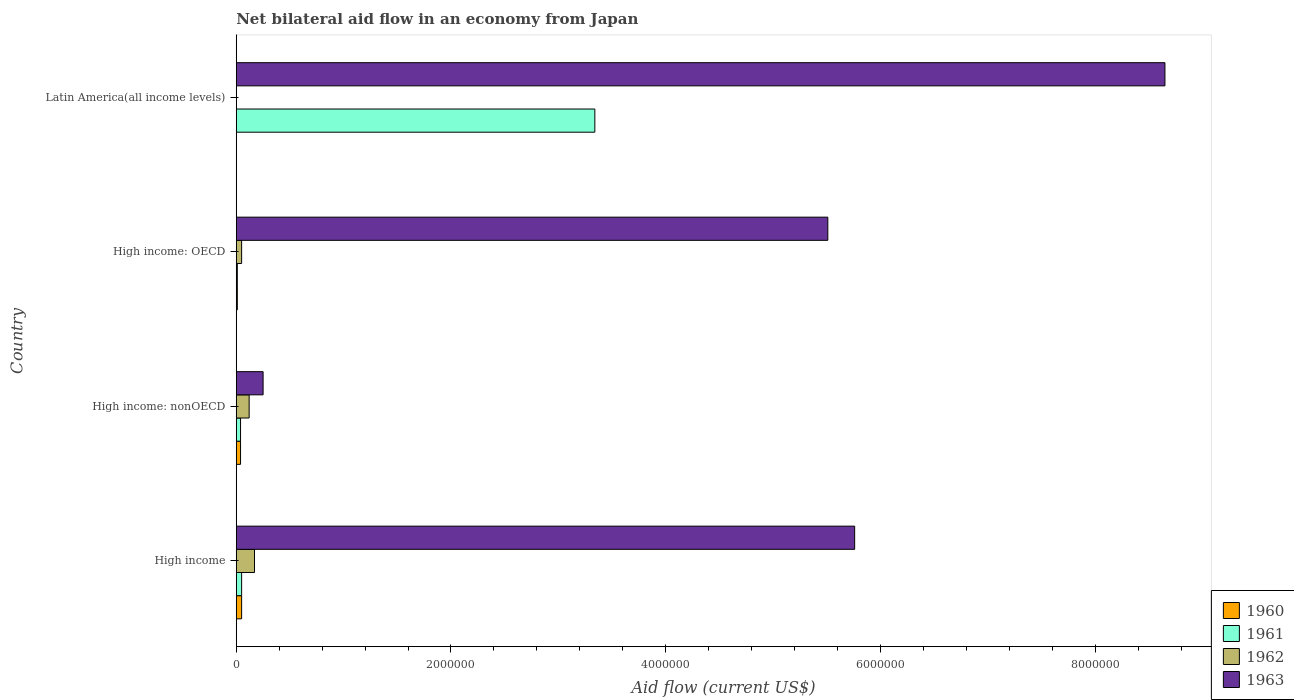What is the label of the 4th group of bars from the top?
Keep it short and to the point. High income. In how many cases, is the number of bars for a given country not equal to the number of legend labels?
Your response must be concise. 1. What is the net bilateral aid flow in 1961 in High income: OECD?
Your response must be concise. 10000. Across all countries, what is the maximum net bilateral aid flow in 1963?
Give a very brief answer. 8.65e+06. Across all countries, what is the minimum net bilateral aid flow in 1962?
Your answer should be very brief. 0. What is the difference between the net bilateral aid flow in 1963 in High income and that in Latin America(all income levels)?
Your answer should be compact. -2.89e+06. What is the average net bilateral aid flow in 1963 per country?
Give a very brief answer. 5.04e+06. What is the difference between the net bilateral aid flow in 1960 and net bilateral aid flow in 1963 in High income: OECD?
Give a very brief answer. -5.50e+06. In how many countries, is the net bilateral aid flow in 1963 greater than 2800000 US$?
Provide a short and direct response. 3. What is the difference between the highest and the second highest net bilateral aid flow in 1961?
Offer a very short reply. 3.29e+06. What is the difference between the highest and the lowest net bilateral aid flow in 1963?
Provide a succinct answer. 8.40e+06. In how many countries, is the net bilateral aid flow in 1961 greater than the average net bilateral aid flow in 1961 taken over all countries?
Offer a very short reply. 1. What is the difference between two consecutive major ticks on the X-axis?
Provide a short and direct response. 2.00e+06. Are the values on the major ticks of X-axis written in scientific E-notation?
Your answer should be compact. No. Does the graph contain any zero values?
Your answer should be very brief. Yes. Where does the legend appear in the graph?
Your answer should be compact. Bottom right. How many legend labels are there?
Give a very brief answer. 4. What is the title of the graph?
Offer a very short reply. Net bilateral aid flow in an economy from Japan. Does "1978" appear as one of the legend labels in the graph?
Offer a terse response. No. What is the Aid flow (current US$) of 1960 in High income?
Provide a succinct answer. 5.00e+04. What is the Aid flow (current US$) of 1963 in High income?
Provide a succinct answer. 5.76e+06. What is the Aid flow (current US$) in 1961 in High income: nonOECD?
Your response must be concise. 4.00e+04. What is the Aid flow (current US$) in 1962 in High income: nonOECD?
Give a very brief answer. 1.20e+05. What is the Aid flow (current US$) in 1963 in High income: nonOECD?
Offer a very short reply. 2.50e+05. What is the Aid flow (current US$) in 1963 in High income: OECD?
Give a very brief answer. 5.51e+06. What is the Aid flow (current US$) of 1960 in Latin America(all income levels)?
Make the answer very short. 0. What is the Aid flow (current US$) in 1961 in Latin America(all income levels)?
Make the answer very short. 3.34e+06. What is the Aid flow (current US$) of 1963 in Latin America(all income levels)?
Provide a succinct answer. 8.65e+06. Across all countries, what is the maximum Aid flow (current US$) in 1960?
Offer a terse response. 5.00e+04. Across all countries, what is the maximum Aid flow (current US$) in 1961?
Your answer should be compact. 3.34e+06. Across all countries, what is the maximum Aid flow (current US$) in 1962?
Your response must be concise. 1.70e+05. Across all countries, what is the maximum Aid flow (current US$) of 1963?
Your answer should be compact. 8.65e+06. Across all countries, what is the minimum Aid flow (current US$) of 1961?
Offer a terse response. 10000. Across all countries, what is the minimum Aid flow (current US$) of 1962?
Provide a short and direct response. 0. Across all countries, what is the minimum Aid flow (current US$) of 1963?
Your answer should be very brief. 2.50e+05. What is the total Aid flow (current US$) in 1961 in the graph?
Ensure brevity in your answer.  3.44e+06. What is the total Aid flow (current US$) in 1962 in the graph?
Your response must be concise. 3.40e+05. What is the total Aid flow (current US$) of 1963 in the graph?
Your response must be concise. 2.02e+07. What is the difference between the Aid flow (current US$) of 1961 in High income and that in High income: nonOECD?
Provide a short and direct response. 10000. What is the difference between the Aid flow (current US$) in 1963 in High income and that in High income: nonOECD?
Your response must be concise. 5.51e+06. What is the difference between the Aid flow (current US$) in 1960 in High income and that in High income: OECD?
Ensure brevity in your answer.  4.00e+04. What is the difference between the Aid flow (current US$) of 1961 in High income and that in High income: OECD?
Give a very brief answer. 4.00e+04. What is the difference between the Aid flow (current US$) of 1962 in High income and that in High income: OECD?
Provide a short and direct response. 1.20e+05. What is the difference between the Aid flow (current US$) of 1961 in High income and that in Latin America(all income levels)?
Provide a succinct answer. -3.29e+06. What is the difference between the Aid flow (current US$) in 1963 in High income and that in Latin America(all income levels)?
Offer a very short reply. -2.89e+06. What is the difference between the Aid flow (current US$) of 1960 in High income: nonOECD and that in High income: OECD?
Your answer should be compact. 3.00e+04. What is the difference between the Aid flow (current US$) in 1961 in High income: nonOECD and that in High income: OECD?
Provide a succinct answer. 3.00e+04. What is the difference between the Aid flow (current US$) in 1963 in High income: nonOECD and that in High income: OECD?
Offer a terse response. -5.26e+06. What is the difference between the Aid flow (current US$) of 1961 in High income: nonOECD and that in Latin America(all income levels)?
Make the answer very short. -3.30e+06. What is the difference between the Aid flow (current US$) of 1963 in High income: nonOECD and that in Latin America(all income levels)?
Your response must be concise. -8.40e+06. What is the difference between the Aid flow (current US$) in 1961 in High income: OECD and that in Latin America(all income levels)?
Ensure brevity in your answer.  -3.33e+06. What is the difference between the Aid flow (current US$) of 1963 in High income: OECD and that in Latin America(all income levels)?
Provide a short and direct response. -3.14e+06. What is the difference between the Aid flow (current US$) of 1960 in High income and the Aid flow (current US$) of 1961 in High income: nonOECD?
Keep it short and to the point. 10000. What is the difference between the Aid flow (current US$) of 1960 in High income and the Aid flow (current US$) of 1962 in High income: nonOECD?
Keep it short and to the point. -7.00e+04. What is the difference between the Aid flow (current US$) of 1960 in High income and the Aid flow (current US$) of 1963 in High income: nonOECD?
Keep it short and to the point. -2.00e+05. What is the difference between the Aid flow (current US$) of 1961 in High income and the Aid flow (current US$) of 1963 in High income: nonOECD?
Your response must be concise. -2.00e+05. What is the difference between the Aid flow (current US$) of 1962 in High income and the Aid flow (current US$) of 1963 in High income: nonOECD?
Provide a short and direct response. -8.00e+04. What is the difference between the Aid flow (current US$) in 1960 in High income and the Aid flow (current US$) in 1961 in High income: OECD?
Ensure brevity in your answer.  4.00e+04. What is the difference between the Aid flow (current US$) of 1960 in High income and the Aid flow (current US$) of 1962 in High income: OECD?
Give a very brief answer. 0. What is the difference between the Aid flow (current US$) of 1960 in High income and the Aid flow (current US$) of 1963 in High income: OECD?
Your answer should be very brief. -5.46e+06. What is the difference between the Aid flow (current US$) of 1961 in High income and the Aid flow (current US$) of 1962 in High income: OECD?
Give a very brief answer. 0. What is the difference between the Aid flow (current US$) in 1961 in High income and the Aid flow (current US$) in 1963 in High income: OECD?
Provide a succinct answer. -5.46e+06. What is the difference between the Aid flow (current US$) of 1962 in High income and the Aid flow (current US$) of 1963 in High income: OECD?
Your answer should be very brief. -5.34e+06. What is the difference between the Aid flow (current US$) in 1960 in High income and the Aid flow (current US$) in 1961 in Latin America(all income levels)?
Provide a succinct answer. -3.29e+06. What is the difference between the Aid flow (current US$) of 1960 in High income and the Aid flow (current US$) of 1963 in Latin America(all income levels)?
Keep it short and to the point. -8.60e+06. What is the difference between the Aid flow (current US$) of 1961 in High income and the Aid flow (current US$) of 1963 in Latin America(all income levels)?
Ensure brevity in your answer.  -8.60e+06. What is the difference between the Aid flow (current US$) of 1962 in High income and the Aid flow (current US$) of 1963 in Latin America(all income levels)?
Ensure brevity in your answer.  -8.48e+06. What is the difference between the Aid flow (current US$) of 1960 in High income: nonOECD and the Aid flow (current US$) of 1961 in High income: OECD?
Offer a terse response. 3.00e+04. What is the difference between the Aid flow (current US$) in 1960 in High income: nonOECD and the Aid flow (current US$) in 1963 in High income: OECD?
Ensure brevity in your answer.  -5.47e+06. What is the difference between the Aid flow (current US$) of 1961 in High income: nonOECD and the Aid flow (current US$) of 1962 in High income: OECD?
Provide a short and direct response. -10000. What is the difference between the Aid flow (current US$) of 1961 in High income: nonOECD and the Aid flow (current US$) of 1963 in High income: OECD?
Ensure brevity in your answer.  -5.47e+06. What is the difference between the Aid flow (current US$) of 1962 in High income: nonOECD and the Aid flow (current US$) of 1963 in High income: OECD?
Offer a terse response. -5.39e+06. What is the difference between the Aid flow (current US$) of 1960 in High income: nonOECD and the Aid flow (current US$) of 1961 in Latin America(all income levels)?
Give a very brief answer. -3.30e+06. What is the difference between the Aid flow (current US$) in 1960 in High income: nonOECD and the Aid flow (current US$) in 1963 in Latin America(all income levels)?
Provide a succinct answer. -8.61e+06. What is the difference between the Aid flow (current US$) of 1961 in High income: nonOECD and the Aid flow (current US$) of 1963 in Latin America(all income levels)?
Give a very brief answer. -8.61e+06. What is the difference between the Aid flow (current US$) of 1962 in High income: nonOECD and the Aid flow (current US$) of 1963 in Latin America(all income levels)?
Provide a succinct answer. -8.53e+06. What is the difference between the Aid flow (current US$) of 1960 in High income: OECD and the Aid flow (current US$) of 1961 in Latin America(all income levels)?
Provide a succinct answer. -3.33e+06. What is the difference between the Aid flow (current US$) of 1960 in High income: OECD and the Aid flow (current US$) of 1963 in Latin America(all income levels)?
Your answer should be very brief. -8.64e+06. What is the difference between the Aid flow (current US$) in 1961 in High income: OECD and the Aid flow (current US$) in 1963 in Latin America(all income levels)?
Provide a short and direct response. -8.64e+06. What is the difference between the Aid flow (current US$) in 1962 in High income: OECD and the Aid flow (current US$) in 1963 in Latin America(all income levels)?
Offer a very short reply. -8.60e+06. What is the average Aid flow (current US$) of 1960 per country?
Provide a succinct answer. 2.50e+04. What is the average Aid flow (current US$) in 1961 per country?
Give a very brief answer. 8.60e+05. What is the average Aid flow (current US$) of 1962 per country?
Your answer should be compact. 8.50e+04. What is the average Aid flow (current US$) of 1963 per country?
Your answer should be compact. 5.04e+06. What is the difference between the Aid flow (current US$) of 1960 and Aid flow (current US$) of 1963 in High income?
Your answer should be very brief. -5.71e+06. What is the difference between the Aid flow (current US$) of 1961 and Aid flow (current US$) of 1962 in High income?
Give a very brief answer. -1.20e+05. What is the difference between the Aid flow (current US$) in 1961 and Aid flow (current US$) in 1963 in High income?
Your answer should be very brief. -5.71e+06. What is the difference between the Aid flow (current US$) in 1962 and Aid flow (current US$) in 1963 in High income?
Make the answer very short. -5.59e+06. What is the difference between the Aid flow (current US$) of 1960 and Aid flow (current US$) of 1961 in High income: nonOECD?
Keep it short and to the point. 0. What is the difference between the Aid flow (current US$) in 1961 and Aid flow (current US$) in 1962 in High income: nonOECD?
Your answer should be compact. -8.00e+04. What is the difference between the Aid flow (current US$) in 1962 and Aid flow (current US$) in 1963 in High income: nonOECD?
Give a very brief answer. -1.30e+05. What is the difference between the Aid flow (current US$) in 1960 and Aid flow (current US$) in 1961 in High income: OECD?
Offer a terse response. 0. What is the difference between the Aid flow (current US$) in 1960 and Aid flow (current US$) in 1963 in High income: OECD?
Your response must be concise. -5.50e+06. What is the difference between the Aid flow (current US$) in 1961 and Aid flow (current US$) in 1962 in High income: OECD?
Give a very brief answer. -4.00e+04. What is the difference between the Aid flow (current US$) of 1961 and Aid flow (current US$) of 1963 in High income: OECD?
Keep it short and to the point. -5.50e+06. What is the difference between the Aid flow (current US$) of 1962 and Aid flow (current US$) of 1963 in High income: OECD?
Your answer should be compact. -5.46e+06. What is the difference between the Aid flow (current US$) in 1961 and Aid flow (current US$) in 1963 in Latin America(all income levels)?
Make the answer very short. -5.31e+06. What is the ratio of the Aid flow (current US$) of 1960 in High income to that in High income: nonOECD?
Make the answer very short. 1.25. What is the ratio of the Aid flow (current US$) in 1961 in High income to that in High income: nonOECD?
Your answer should be very brief. 1.25. What is the ratio of the Aid flow (current US$) in 1962 in High income to that in High income: nonOECD?
Give a very brief answer. 1.42. What is the ratio of the Aid flow (current US$) in 1963 in High income to that in High income: nonOECD?
Your answer should be very brief. 23.04. What is the ratio of the Aid flow (current US$) in 1960 in High income to that in High income: OECD?
Your response must be concise. 5. What is the ratio of the Aid flow (current US$) in 1963 in High income to that in High income: OECD?
Provide a short and direct response. 1.05. What is the ratio of the Aid flow (current US$) of 1961 in High income to that in Latin America(all income levels)?
Make the answer very short. 0.01. What is the ratio of the Aid flow (current US$) of 1963 in High income to that in Latin America(all income levels)?
Keep it short and to the point. 0.67. What is the ratio of the Aid flow (current US$) in 1960 in High income: nonOECD to that in High income: OECD?
Provide a succinct answer. 4. What is the ratio of the Aid flow (current US$) of 1963 in High income: nonOECD to that in High income: OECD?
Offer a very short reply. 0.05. What is the ratio of the Aid flow (current US$) of 1961 in High income: nonOECD to that in Latin America(all income levels)?
Give a very brief answer. 0.01. What is the ratio of the Aid flow (current US$) in 1963 in High income: nonOECD to that in Latin America(all income levels)?
Your response must be concise. 0.03. What is the ratio of the Aid flow (current US$) in 1961 in High income: OECD to that in Latin America(all income levels)?
Offer a terse response. 0. What is the ratio of the Aid flow (current US$) of 1963 in High income: OECD to that in Latin America(all income levels)?
Offer a terse response. 0.64. What is the difference between the highest and the second highest Aid flow (current US$) of 1961?
Make the answer very short. 3.29e+06. What is the difference between the highest and the second highest Aid flow (current US$) in 1963?
Provide a succinct answer. 2.89e+06. What is the difference between the highest and the lowest Aid flow (current US$) in 1961?
Provide a short and direct response. 3.33e+06. What is the difference between the highest and the lowest Aid flow (current US$) in 1962?
Your answer should be very brief. 1.70e+05. What is the difference between the highest and the lowest Aid flow (current US$) in 1963?
Your response must be concise. 8.40e+06. 